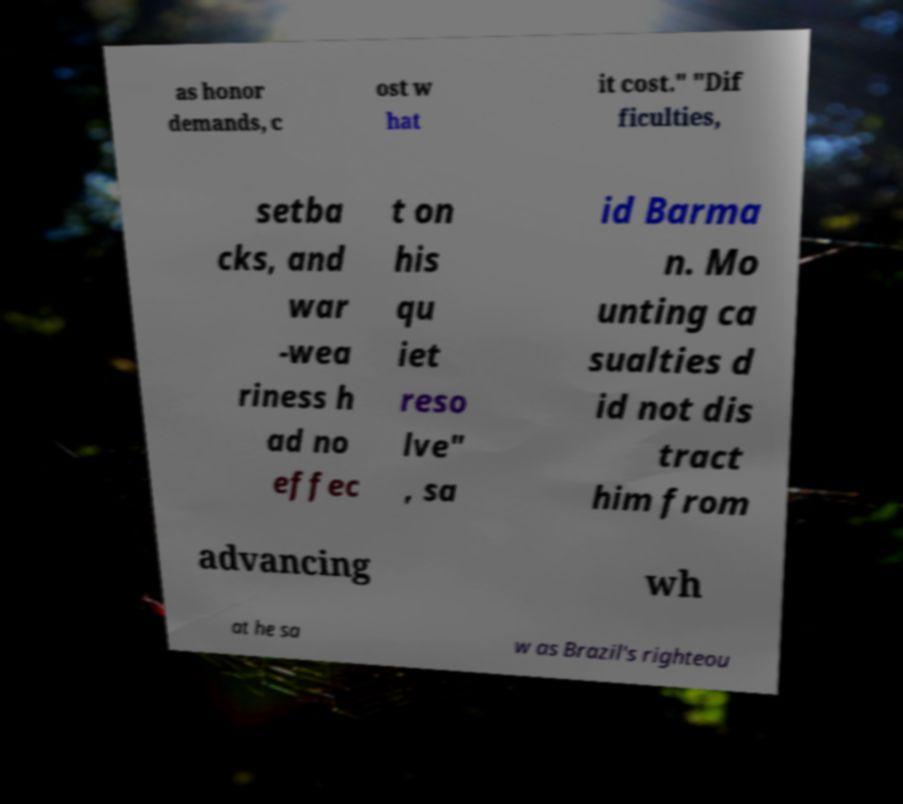Can you accurately transcribe the text from the provided image for me? as honor demands, c ost w hat it cost." "Dif ficulties, setba cks, and war -wea riness h ad no effec t on his qu iet reso lve" , sa id Barma n. Mo unting ca sualties d id not dis tract him from advancing wh at he sa w as Brazil's righteou 